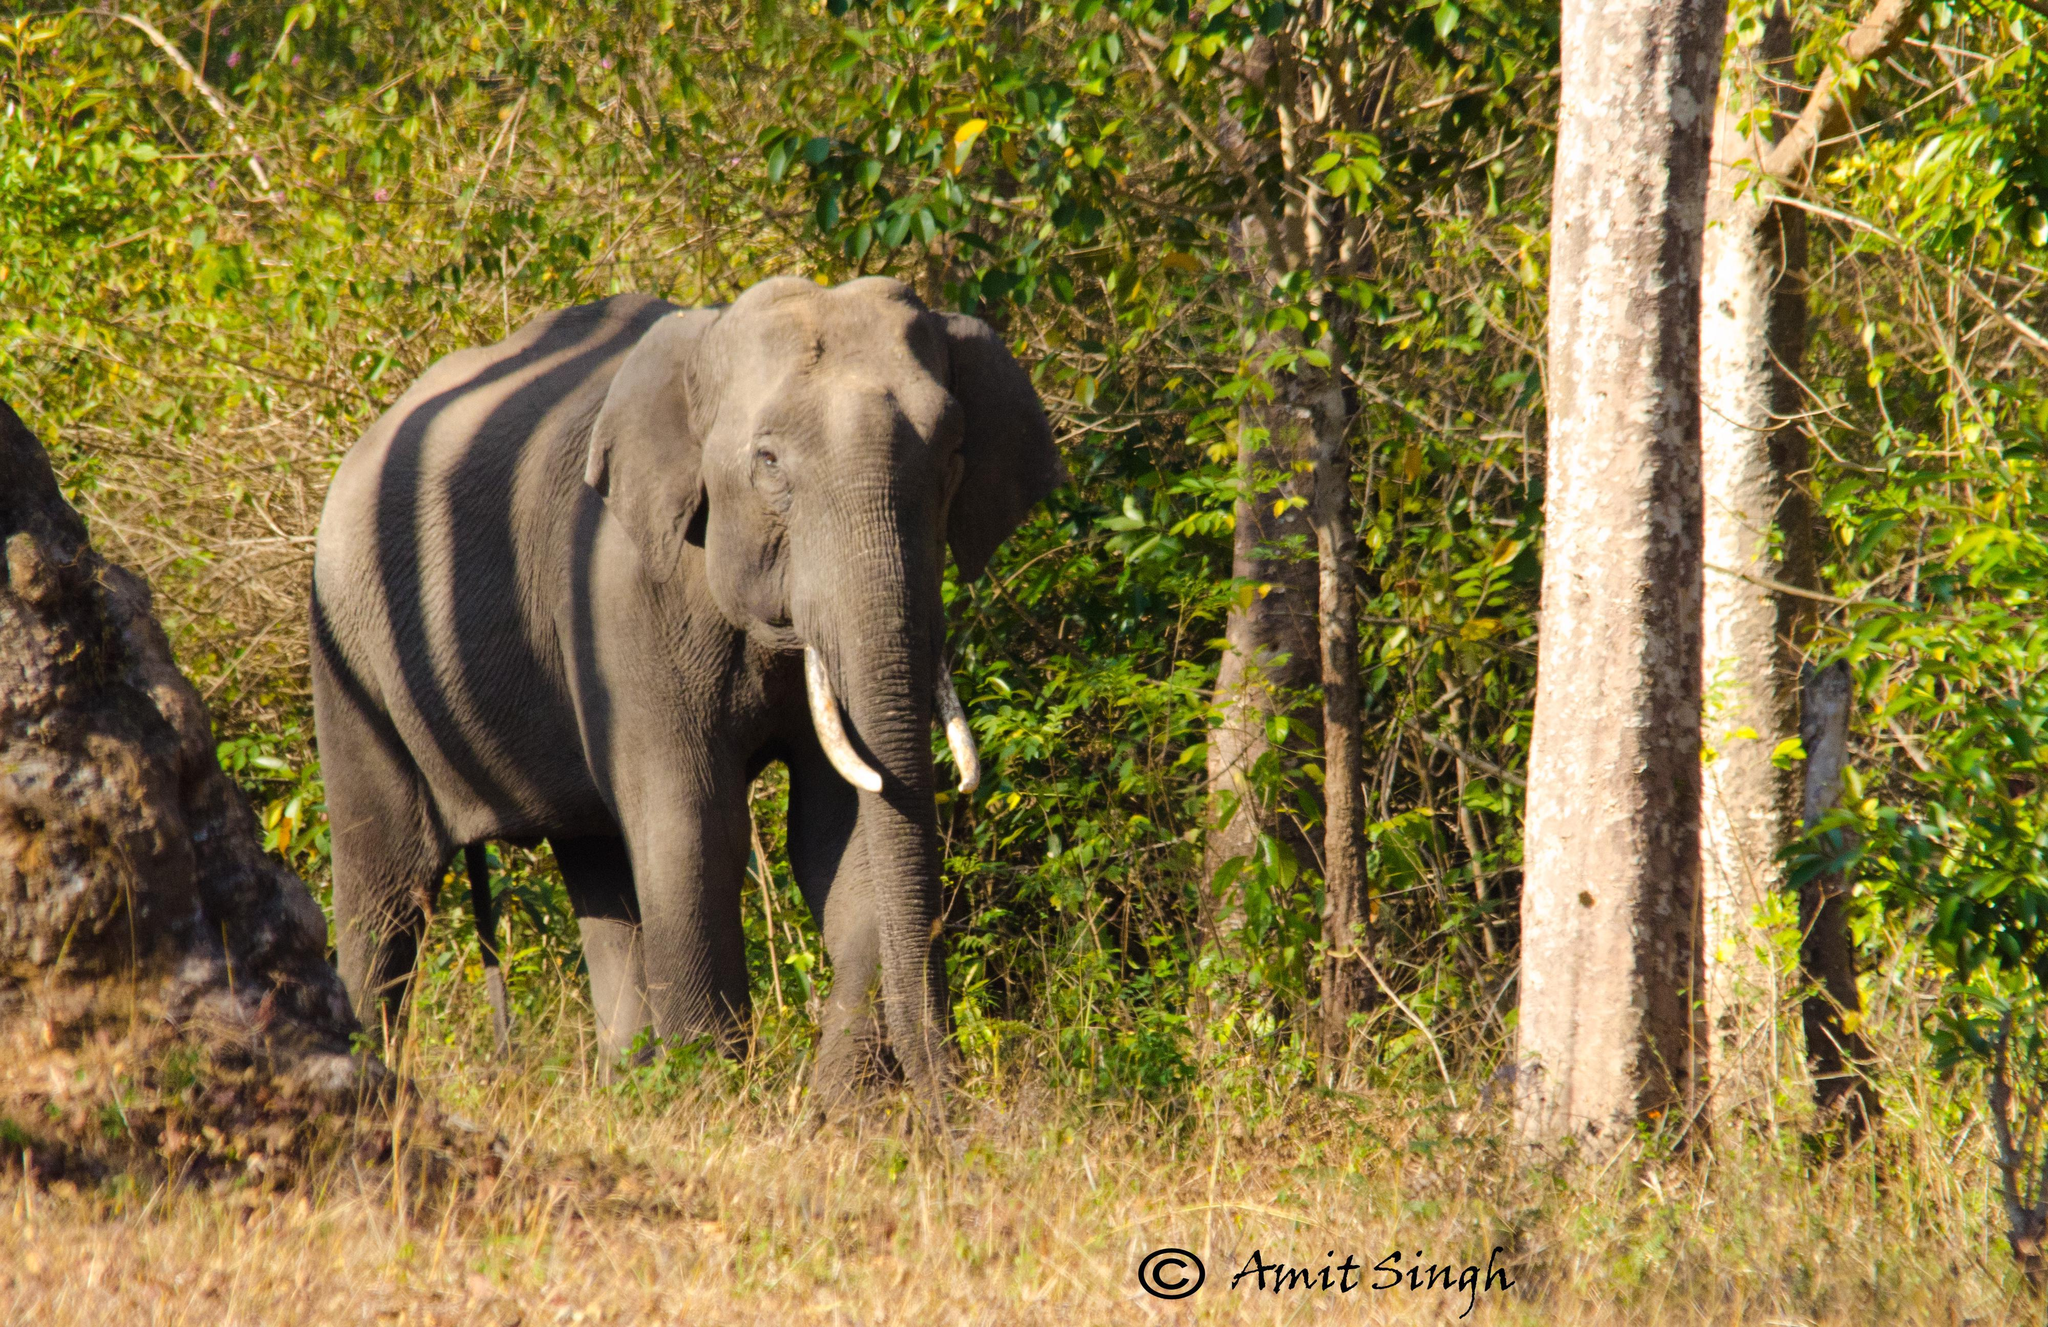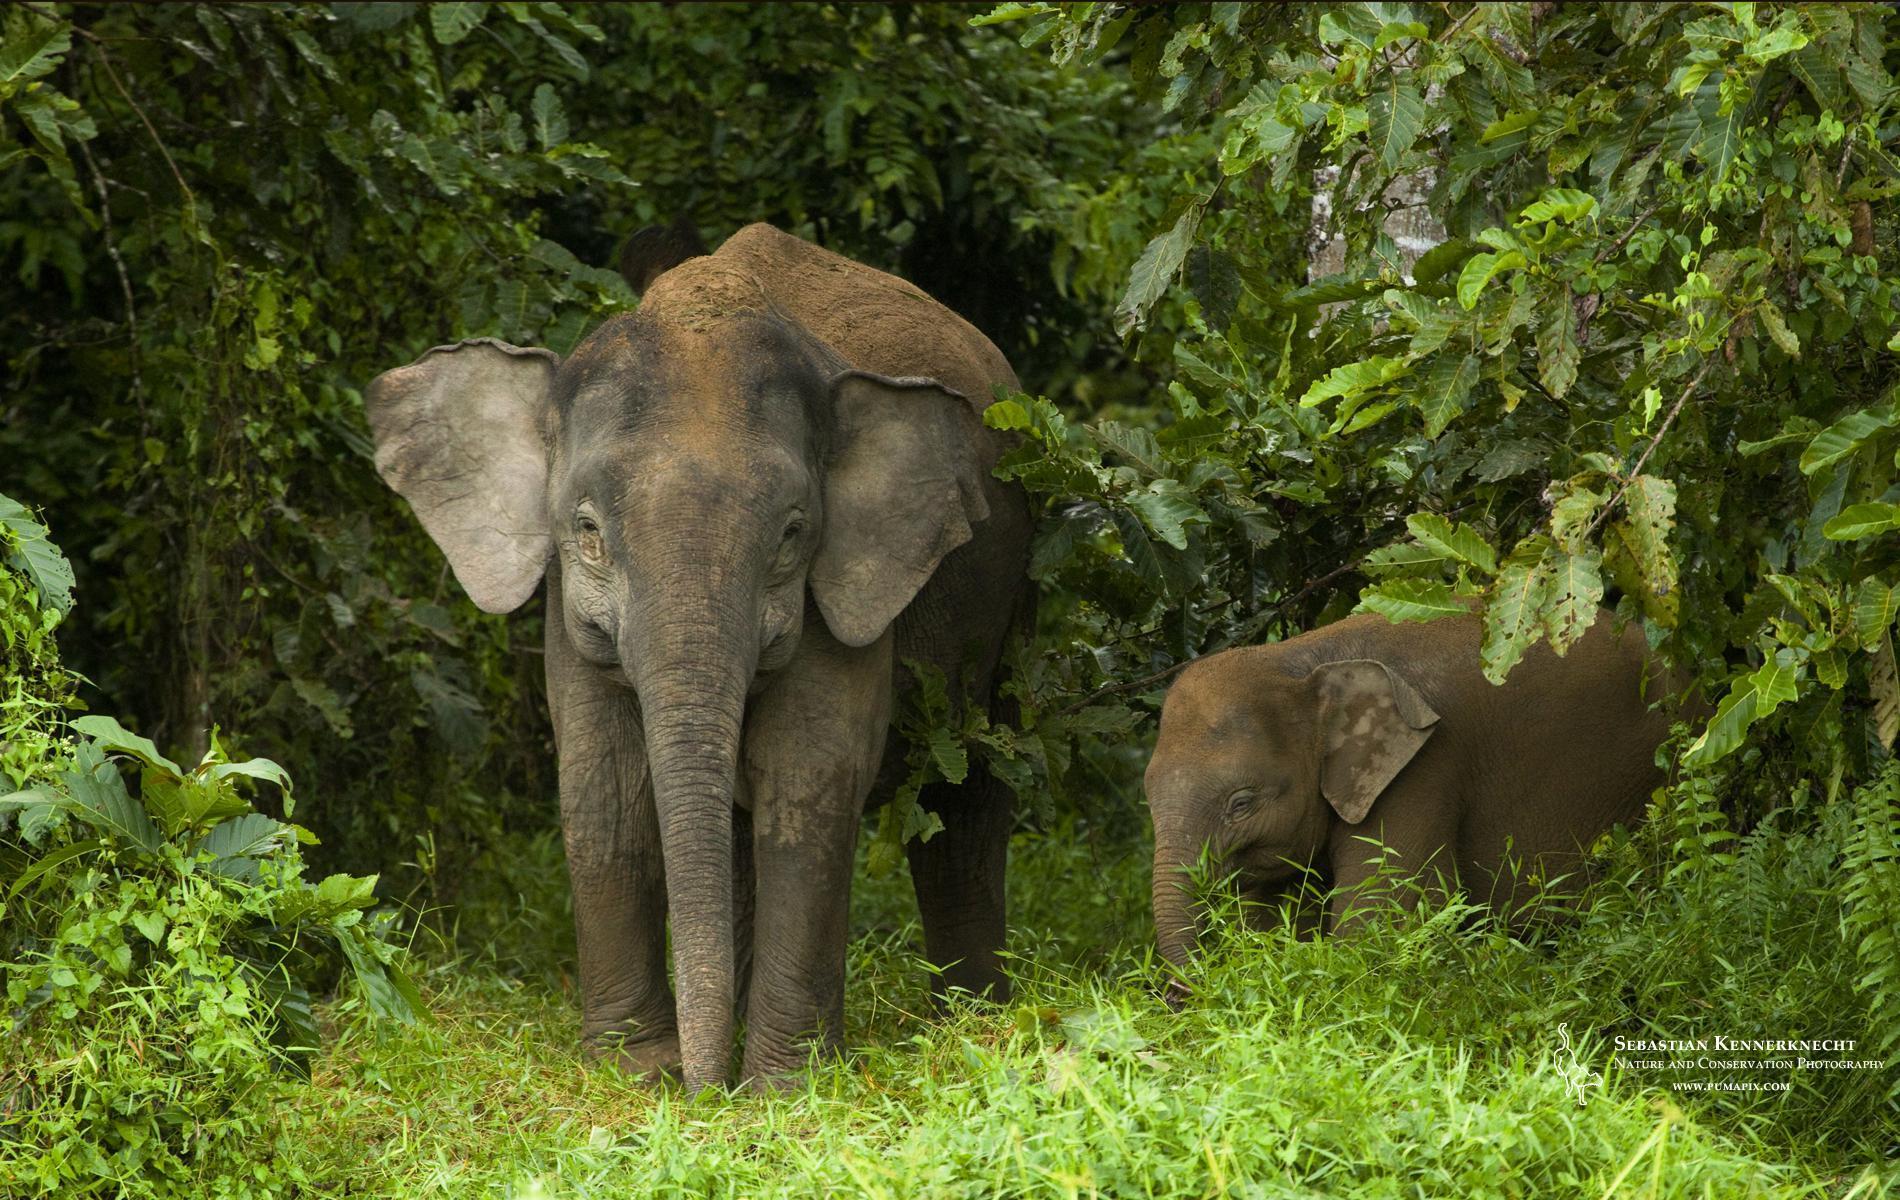The first image is the image on the left, the second image is the image on the right. Examine the images to the left and right. Is the description "An elephant with tusks has the end of his trunk curled and raised up." accurate? Answer yes or no. No. The first image is the image on the left, the second image is the image on the right. For the images displayed, is the sentence "The elephant in the left image is near the water." factually correct? Answer yes or no. No. 